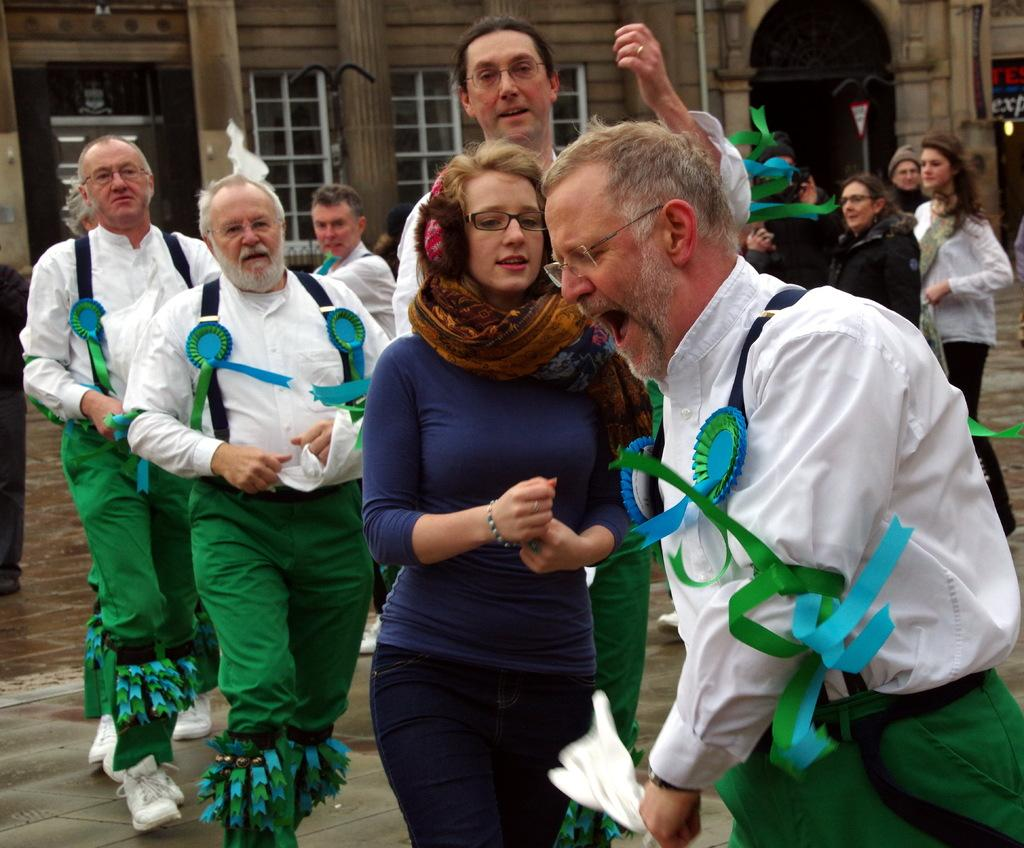What is happening on the floor in the image? There are many persons on the floor in the image. What can be seen in the distance in the image? There are buildings in the background of the image. Can you describe any architectural features in the background? Yes, there is at least one pillar in the background of the image. What else can be seen in the background? There are windows in the background of the image. What type of sticks are being used by the guide in the image? There is no guide or sticks present in the image. 